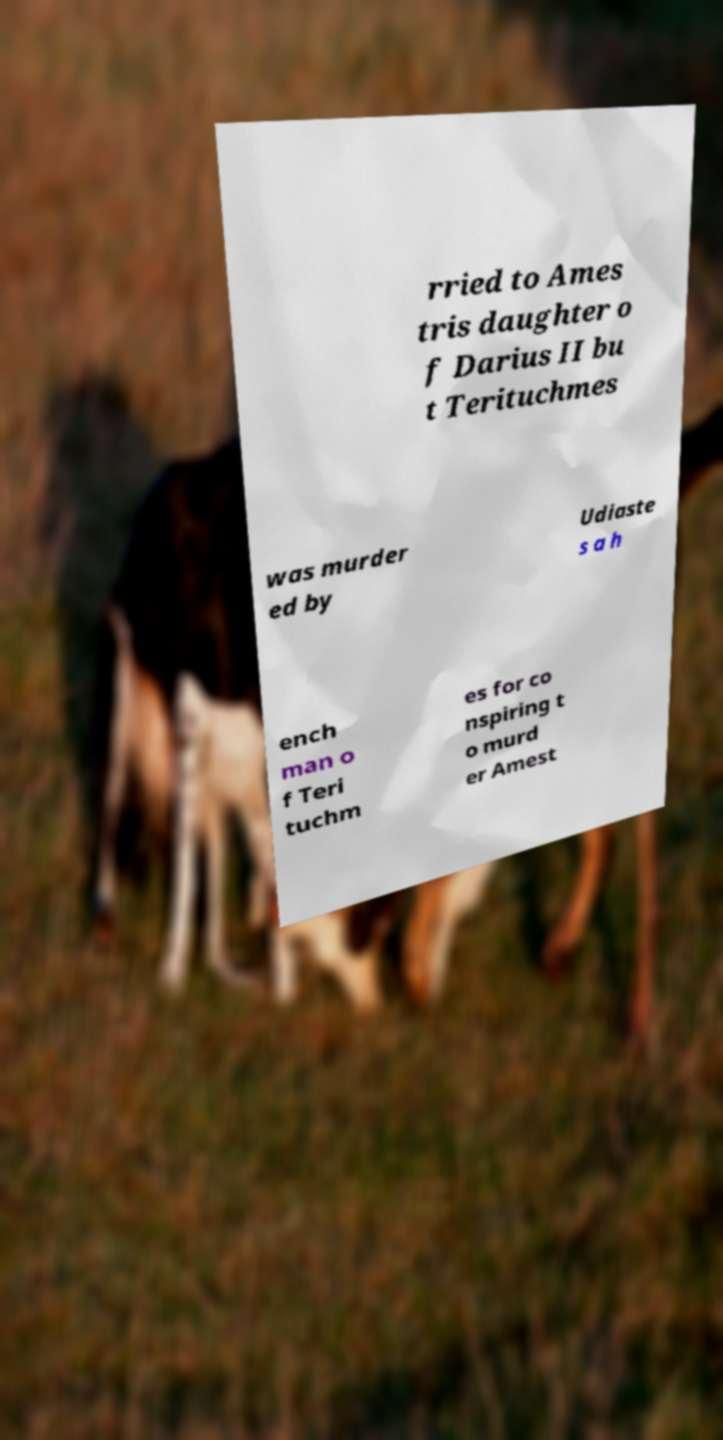For documentation purposes, I need the text within this image transcribed. Could you provide that? rried to Ames tris daughter o f Darius II bu t Terituchmes was murder ed by Udiaste s a h ench man o f Teri tuchm es for co nspiring t o murd er Amest 